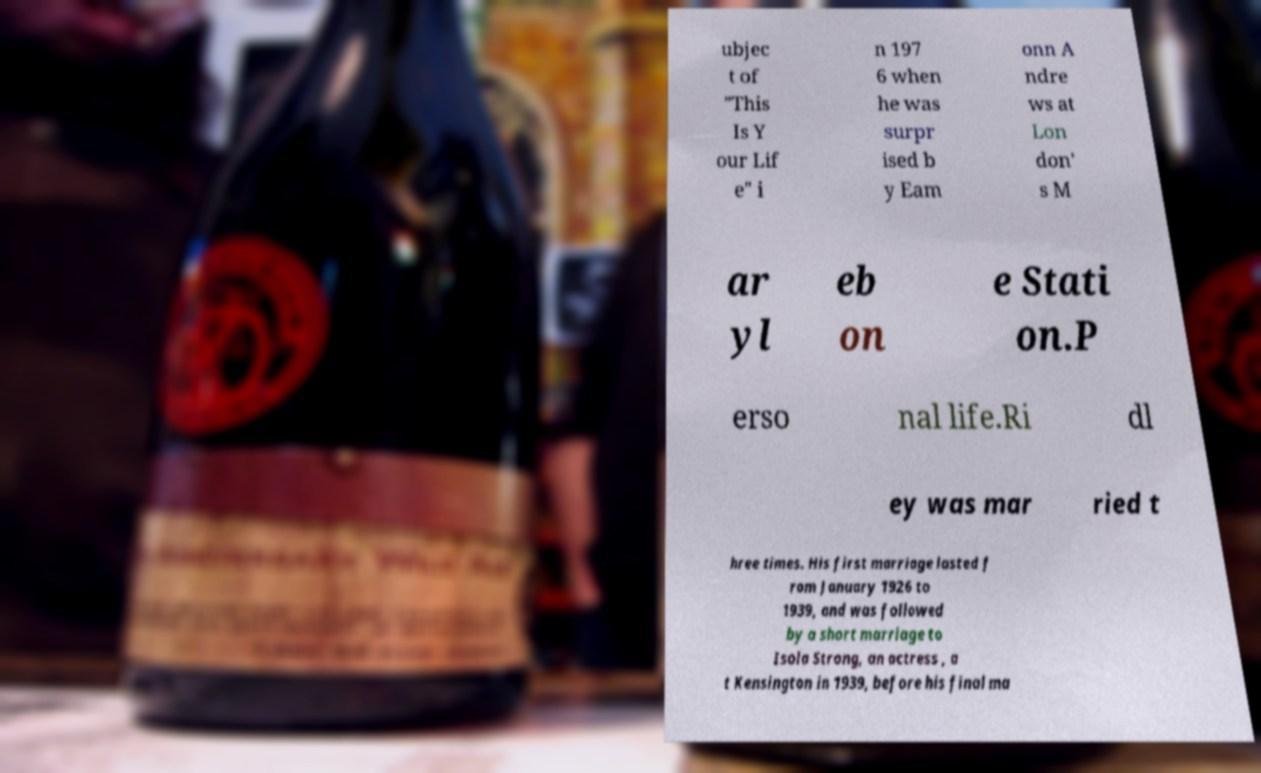Can you read and provide the text displayed in the image?This photo seems to have some interesting text. Can you extract and type it out for me? ubjec t of "This Is Y our Lif e" i n 197 6 when he was surpr ised b y Eam onn A ndre ws at Lon don' s M ar yl eb on e Stati on.P erso nal life.Ri dl ey was mar ried t hree times. His first marriage lasted f rom January 1926 to 1939, and was followed by a short marriage to Isola Strong, an actress , a t Kensington in 1939, before his final ma 